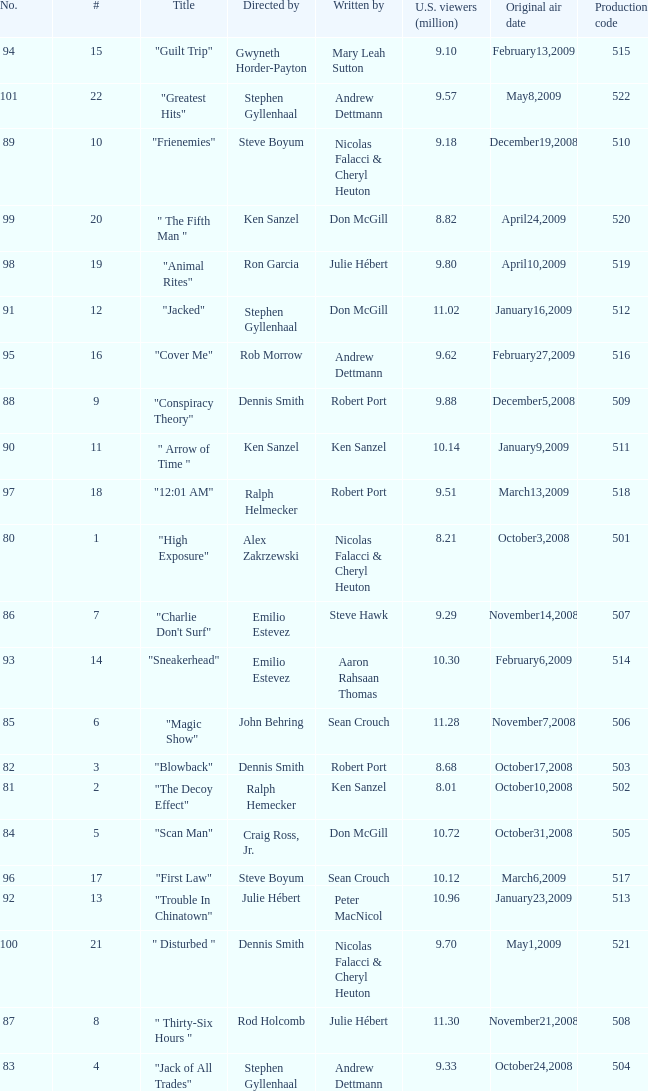What episode number was directed by Craig Ross, Jr. 5.0. 